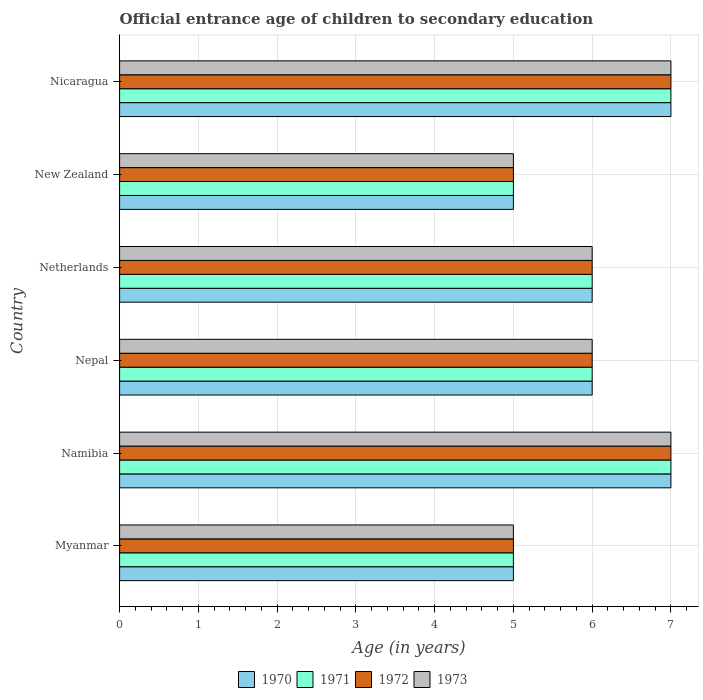How many different coloured bars are there?
Your answer should be very brief. 4. How many bars are there on the 6th tick from the top?
Your answer should be very brief. 4. How many bars are there on the 5th tick from the bottom?
Your response must be concise. 4. What is the label of the 3rd group of bars from the top?
Give a very brief answer. Netherlands. In how many cases, is the number of bars for a given country not equal to the number of legend labels?
Make the answer very short. 0. What is the secondary school starting age of children in 1971 in Namibia?
Your response must be concise. 7. In which country was the secondary school starting age of children in 1970 maximum?
Provide a succinct answer. Namibia. In which country was the secondary school starting age of children in 1970 minimum?
Your answer should be compact. Myanmar. What is the total secondary school starting age of children in 1971 in the graph?
Provide a short and direct response. 36. What is the difference between the secondary school starting age of children in 1970 and secondary school starting age of children in 1973 in Nepal?
Give a very brief answer. 0. What is the ratio of the secondary school starting age of children in 1973 in Myanmar to that in Namibia?
Your answer should be very brief. 0.71. Is the secondary school starting age of children in 1972 in New Zealand less than that in Nicaragua?
Ensure brevity in your answer.  Yes. What is the difference between the highest and the second highest secondary school starting age of children in 1970?
Ensure brevity in your answer.  0. Is the sum of the secondary school starting age of children in 1970 in Myanmar and Nepal greater than the maximum secondary school starting age of children in 1973 across all countries?
Give a very brief answer. Yes. Is it the case that in every country, the sum of the secondary school starting age of children in 1971 and secondary school starting age of children in 1973 is greater than the sum of secondary school starting age of children in 1970 and secondary school starting age of children in 1972?
Provide a succinct answer. No. Is it the case that in every country, the sum of the secondary school starting age of children in 1972 and secondary school starting age of children in 1971 is greater than the secondary school starting age of children in 1970?
Keep it short and to the point. Yes. How many bars are there?
Ensure brevity in your answer.  24. Are all the bars in the graph horizontal?
Your answer should be compact. Yes. Does the graph contain any zero values?
Your answer should be very brief. No. Does the graph contain grids?
Ensure brevity in your answer.  Yes. How are the legend labels stacked?
Make the answer very short. Horizontal. What is the title of the graph?
Your response must be concise. Official entrance age of children to secondary education. Does "2006" appear as one of the legend labels in the graph?
Give a very brief answer. No. What is the label or title of the X-axis?
Your answer should be compact. Age (in years). What is the Age (in years) in 1970 in Myanmar?
Offer a terse response. 5. What is the Age (in years) of 1971 in Myanmar?
Keep it short and to the point. 5. What is the Age (in years) in 1972 in Myanmar?
Give a very brief answer. 5. What is the Age (in years) in 1971 in Namibia?
Give a very brief answer. 7. What is the Age (in years) in 1973 in Namibia?
Ensure brevity in your answer.  7. What is the Age (in years) in 1971 in Nepal?
Offer a very short reply. 6. What is the Age (in years) in 1973 in Nepal?
Provide a short and direct response. 6. What is the Age (in years) of 1970 in Netherlands?
Ensure brevity in your answer.  6. What is the Age (in years) of 1970 in New Zealand?
Keep it short and to the point. 5. What is the Age (in years) in 1971 in New Zealand?
Provide a succinct answer. 5. What is the Age (in years) in 1972 in New Zealand?
Provide a short and direct response. 5. What is the Age (in years) of 1970 in Nicaragua?
Your response must be concise. 7. What is the Age (in years) of 1971 in Nicaragua?
Provide a succinct answer. 7. What is the Age (in years) of 1972 in Nicaragua?
Keep it short and to the point. 7. What is the Age (in years) of 1973 in Nicaragua?
Make the answer very short. 7. Across all countries, what is the maximum Age (in years) of 1970?
Give a very brief answer. 7. Across all countries, what is the maximum Age (in years) in 1971?
Your answer should be very brief. 7. Across all countries, what is the maximum Age (in years) in 1973?
Offer a terse response. 7. Across all countries, what is the minimum Age (in years) in 1971?
Your response must be concise. 5. What is the total Age (in years) of 1970 in the graph?
Ensure brevity in your answer.  36. What is the total Age (in years) of 1971 in the graph?
Make the answer very short. 36. What is the total Age (in years) of 1973 in the graph?
Provide a succinct answer. 36. What is the difference between the Age (in years) of 1970 in Myanmar and that in Nepal?
Keep it short and to the point. -1. What is the difference between the Age (in years) of 1972 in Myanmar and that in Nepal?
Offer a terse response. -1. What is the difference between the Age (in years) in 1973 in Myanmar and that in Nepal?
Your answer should be compact. -1. What is the difference between the Age (in years) of 1973 in Myanmar and that in Netherlands?
Offer a very short reply. -1. What is the difference between the Age (in years) of 1971 in Myanmar and that in Nicaragua?
Provide a succinct answer. -2. What is the difference between the Age (in years) in 1973 in Namibia and that in Nepal?
Offer a very short reply. 1. What is the difference between the Age (in years) in 1970 in Namibia and that in Netherlands?
Ensure brevity in your answer.  1. What is the difference between the Age (in years) of 1972 in Namibia and that in Netherlands?
Ensure brevity in your answer.  1. What is the difference between the Age (in years) of 1973 in Namibia and that in Netherlands?
Provide a short and direct response. 1. What is the difference between the Age (in years) in 1971 in Namibia and that in New Zealand?
Make the answer very short. 2. What is the difference between the Age (in years) in 1973 in Namibia and that in New Zealand?
Offer a very short reply. 2. What is the difference between the Age (in years) of 1971 in Namibia and that in Nicaragua?
Your response must be concise. 0. What is the difference between the Age (in years) in 1972 in Namibia and that in Nicaragua?
Your response must be concise. 0. What is the difference between the Age (in years) of 1973 in Namibia and that in Nicaragua?
Your answer should be very brief. 0. What is the difference between the Age (in years) in 1970 in Nepal and that in New Zealand?
Offer a very short reply. 1. What is the difference between the Age (in years) of 1971 in Nepal and that in New Zealand?
Give a very brief answer. 1. What is the difference between the Age (in years) of 1971 in Nepal and that in Nicaragua?
Make the answer very short. -1. What is the difference between the Age (in years) in 1972 in Nepal and that in Nicaragua?
Provide a short and direct response. -1. What is the difference between the Age (in years) of 1970 in Netherlands and that in Nicaragua?
Your answer should be compact. -1. What is the difference between the Age (in years) of 1970 in New Zealand and that in Nicaragua?
Make the answer very short. -2. What is the difference between the Age (in years) of 1972 in New Zealand and that in Nicaragua?
Keep it short and to the point. -2. What is the difference between the Age (in years) of 1970 in Myanmar and the Age (in years) of 1971 in Namibia?
Keep it short and to the point. -2. What is the difference between the Age (in years) in 1970 in Myanmar and the Age (in years) in 1973 in Namibia?
Provide a succinct answer. -2. What is the difference between the Age (in years) in 1971 in Myanmar and the Age (in years) in 1972 in Namibia?
Provide a short and direct response. -2. What is the difference between the Age (in years) of 1970 in Myanmar and the Age (in years) of 1971 in Nepal?
Your answer should be compact. -1. What is the difference between the Age (in years) in 1970 in Myanmar and the Age (in years) in 1972 in Nepal?
Make the answer very short. -1. What is the difference between the Age (in years) of 1971 in Myanmar and the Age (in years) of 1973 in Nepal?
Give a very brief answer. -1. What is the difference between the Age (in years) of 1970 in Myanmar and the Age (in years) of 1971 in Netherlands?
Give a very brief answer. -1. What is the difference between the Age (in years) in 1970 in Myanmar and the Age (in years) in 1972 in Netherlands?
Make the answer very short. -1. What is the difference between the Age (in years) in 1971 in Myanmar and the Age (in years) in 1972 in Netherlands?
Give a very brief answer. -1. What is the difference between the Age (in years) of 1971 in Myanmar and the Age (in years) of 1973 in Netherlands?
Offer a very short reply. -1. What is the difference between the Age (in years) of 1970 in Myanmar and the Age (in years) of 1971 in New Zealand?
Ensure brevity in your answer.  0. What is the difference between the Age (in years) of 1970 in Myanmar and the Age (in years) of 1972 in New Zealand?
Ensure brevity in your answer.  0. What is the difference between the Age (in years) in 1971 in Myanmar and the Age (in years) in 1973 in New Zealand?
Give a very brief answer. 0. What is the difference between the Age (in years) in 1972 in Myanmar and the Age (in years) in 1973 in New Zealand?
Provide a succinct answer. 0. What is the difference between the Age (in years) of 1970 in Myanmar and the Age (in years) of 1972 in Nicaragua?
Keep it short and to the point. -2. What is the difference between the Age (in years) of 1970 in Myanmar and the Age (in years) of 1973 in Nicaragua?
Make the answer very short. -2. What is the difference between the Age (in years) of 1971 in Myanmar and the Age (in years) of 1972 in Nicaragua?
Your answer should be compact. -2. What is the difference between the Age (in years) in 1971 in Myanmar and the Age (in years) in 1973 in Nicaragua?
Your response must be concise. -2. What is the difference between the Age (in years) of 1972 in Myanmar and the Age (in years) of 1973 in Nicaragua?
Your response must be concise. -2. What is the difference between the Age (in years) in 1970 in Namibia and the Age (in years) in 1973 in Nepal?
Ensure brevity in your answer.  1. What is the difference between the Age (in years) in 1971 in Namibia and the Age (in years) in 1972 in Nepal?
Ensure brevity in your answer.  1. What is the difference between the Age (in years) of 1971 in Namibia and the Age (in years) of 1973 in Nepal?
Offer a very short reply. 1. What is the difference between the Age (in years) of 1971 in Namibia and the Age (in years) of 1972 in Netherlands?
Give a very brief answer. 1. What is the difference between the Age (in years) in 1972 in Namibia and the Age (in years) in 1973 in Netherlands?
Provide a succinct answer. 1. What is the difference between the Age (in years) in 1970 in Namibia and the Age (in years) in 1971 in New Zealand?
Your response must be concise. 2. What is the difference between the Age (in years) in 1970 in Namibia and the Age (in years) in 1973 in New Zealand?
Provide a succinct answer. 2. What is the difference between the Age (in years) in 1970 in Namibia and the Age (in years) in 1972 in Nicaragua?
Your response must be concise. 0. What is the difference between the Age (in years) in 1970 in Namibia and the Age (in years) in 1973 in Nicaragua?
Your answer should be compact. 0. What is the difference between the Age (in years) of 1971 in Namibia and the Age (in years) of 1973 in Nicaragua?
Ensure brevity in your answer.  0. What is the difference between the Age (in years) of 1970 in Nepal and the Age (in years) of 1971 in Netherlands?
Ensure brevity in your answer.  0. What is the difference between the Age (in years) of 1970 in Nepal and the Age (in years) of 1972 in Netherlands?
Keep it short and to the point. 0. What is the difference between the Age (in years) in 1971 in Nepal and the Age (in years) in 1973 in Netherlands?
Your response must be concise. 0. What is the difference between the Age (in years) of 1970 in Nepal and the Age (in years) of 1971 in New Zealand?
Your answer should be very brief. 1. What is the difference between the Age (in years) of 1970 in Nepal and the Age (in years) of 1973 in New Zealand?
Keep it short and to the point. 1. What is the difference between the Age (in years) of 1971 in Nepal and the Age (in years) of 1972 in New Zealand?
Your response must be concise. 1. What is the difference between the Age (in years) of 1972 in Nepal and the Age (in years) of 1973 in New Zealand?
Your response must be concise. 1. What is the difference between the Age (in years) in 1970 in Nepal and the Age (in years) in 1971 in Nicaragua?
Keep it short and to the point. -1. What is the difference between the Age (in years) of 1970 in Nepal and the Age (in years) of 1973 in Nicaragua?
Provide a short and direct response. -1. What is the difference between the Age (in years) in 1972 in Nepal and the Age (in years) in 1973 in Nicaragua?
Offer a very short reply. -1. What is the difference between the Age (in years) of 1971 in Netherlands and the Age (in years) of 1972 in New Zealand?
Offer a very short reply. 1. What is the difference between the Age (in years) of 1970 in Netherlands and the Age (in years) of 1971 in Nicaragua?
Provide a short and direct response. -1. What is the difference between the Age (in years) of 1970 in Netherlands and the Age (in years) of 1972 in Nicaragua?
Offer a terse response. -1. What is the difference between the Age (in years) of 1970 in Netherlands and the Age (in years) of 1973 in Nicaragua?
Offer a terse response. -1. What is the difference between the Age (in years) in 1971 in Netherlands and the Age (in years) in 1973 in Nicaragua?
Give a very brief answer. -1. What is the difference between the Age (in years) of 1970 in New Zealand and the Age (in years) of 1972 in Nicaragua?
Offer a terse response. -2. What is the difference between the Age (in years) in 1970 in New Zealand and the Age (in years) in 1973 in Nicaragua?
Your answer should be compact. -2. What is the difference between the Age (in years) of 1971 in New Zealand and the Age (in years) of 1972 in Nicaragua?
Your answer should be very brief. -2. What is the difference between the Age (in years) of 1972 in New Zealand and the Age (in years) of 1973 in Nicaragua?
Keep it short and to the point. -2. What is the average Age (in years) of 1971 per country?
Your answer should be compact. 6. What is the average Age (in years) of 1972 per country?
Provide a succinct answer. 6. What is the difference between the Age (in years) in 1970 and Age (in years) in 1972 in Myanmar?
Your answer should be very brief. 0. What is the difference between the Age (in years) of 1970 and Age (in years) of 1971 in Nepal?
Offer a terse response. 0. What is the difference between the Age (in years) of 1970 and Age (in years) of 1973 in Nepal?
Your answer should be compact. 0. What is the difference between the Age (in years) in 1971 and Age (in years) in 1972 in Nepal?
Offer a very short reply. 0. What is the difference between the Age (in years) of 1970 and Age (in years) of 1971 in Netherlands?
Your answer should be compact. 0. What is the difference between the Age (in years) of 1970 and Age (in years) of 1972 in Netherlands?
Your answer should be compact. 0. What is the difference between the Age (in years) in 1970 and Age (in years) in 1973 in Netherlands?
Provide a succinct answer. 0. What is the difference between the Age (in years) in 1970 and Age (in years) in 1971 in New Zealand?
Keep it short and to the point. 0. What is the difference between the Age (in years) in 1971 and Age (in years) in 1972 in New Zealand?
Your response must be concise. 0. What is the difference between the Age (in years) in 1971 and Age (in years) in 1973 in New Zealand?
Offer a terse response. 0. What is the difference between the Age (in years) in 1970 and Age (in years) in 1971 in Nicaragua?
Give a very brief answer. 0. What is the difference between the Age (in years) of 1971 and Age (in years) of 1972 in Nicaragua?
Provide a succinct answer. 0. What is the ratio of the Age (in years) of 1970 in Myanmar to that in Namibia?
Your answer should be very brief. 0.71. What is the ratio of the Age (in years) in 1970 in Myanmar to that in Nepal?
Ensure brevity in your answer.  0.83. What is the ratio of the Age (in years) in 1971 in Myanmar to that in Nepal?
Your response must be concise. 0.83. What is the ratio of the Age (in years) in 1972 in Myanmar to that in Nepal?
Ensure brevity in your answer.  0.83. What is the ratio of the Age (in years) of 1972 in Myanmar to that in Netherlands?
Provide a succinct answer. 0.83. What is the ratio of the Age (in years) of 1973 in Myanmar to that in Netherlands?
Your answer should be very brief. 0.83. What is the ratio of the Age (in years) of 1970 in Myanmar to that in New Zealand?
Keep it short and to the point. 1. What is the ratio of the Age (in years) in 1973 in Myanmar to that in New Zealand?
Your response must be concise. 1. What is the ratio of the Age (in years) of 1970 in Myanmar to that in Nicaragua?
Provide a short and direct response. 0.71. What is the ratio of the Age (in years) of 1971 in Myanmar to that in Nicaragua?
Your answer should be very brief. 0.71. What is the ratio of the Age (in years) in 1973 in Myanmar to that in Nicaragua?
Provide a short and direct response. 0.71. What is the ratio of the Age (in years) of 1971 in Namibia to that in Nepal?
Ensure brevity in your answer.  1.17. What is the ratio of the Age (in years) in 1970 in Namibia to that in Netherlands?
Your answer should be compact. 1.17. What is the ratio of the Age (in years) in 1971 in Namibia to that in Netherlands?
Your answer should be compact. 1.17. What is the ratio of the Age (in years) of 1972 in Namibia to that in Netherlands?
Make the answer very short. 1.17. What is the ratio of the Age (in years) in 1973 in Namibia to that in Netherlands?
Keep it short and to the point. 1.17. What is the ratio of the Age (in years) of 1973 in Namibia to that in Nicaragua?
Your answer should be compact. 1. What is the ratio of the Age (in years) of 1970 in Nepal to that in Netherlands?
Offer a very short reply. 1. What is the ratio of the Age (in years) in 1970 in Nepal to that in New Zealand?
Provide a succinct answer. 1.2. What is the ratio of the Age (in years) of 1971 in Nepal to that in New Zealand?
Provide a succinct answer. 1.2. What is the ratio of the Age (in years) of 1973 in Nepal to that in Nicaragua?
Your answer should be very brief. 0.86. What is the ratio of the Age (in years) in 1971 in Netherlands to that in New Zealand?
Make the answer very short. 1.2. What is the ratio of the Age (in years) in 1970 in Netherlands to that in Nicaragua?
Your answer should be compact. 0.86. What is the ratio of the Age (in years) in 1972 in Netherlands to that in Nicaragua?
Offer a terse response. 0.86. What is the ratio of the Age (in years) in 1973 in Netherlands to that in Nicaragua?
Give a very brief answer. 0.86. What is the ratio of the Age (in years) of 1970 in New Zealand to that in Nicaragua?
Your response must be concise. 0.71. What is the ratio of the Age (in years) of 1973 in New Zealand to that in Nicaragua?
Your response must be concise. 0.71. What is the difference between the highest and the second highest Age (in years) of 1970?
Ensure brevity in your answer.  0. What is the difference between the highest and the lowest Age (in years) in 1972?
Offer a terse response. 2. 